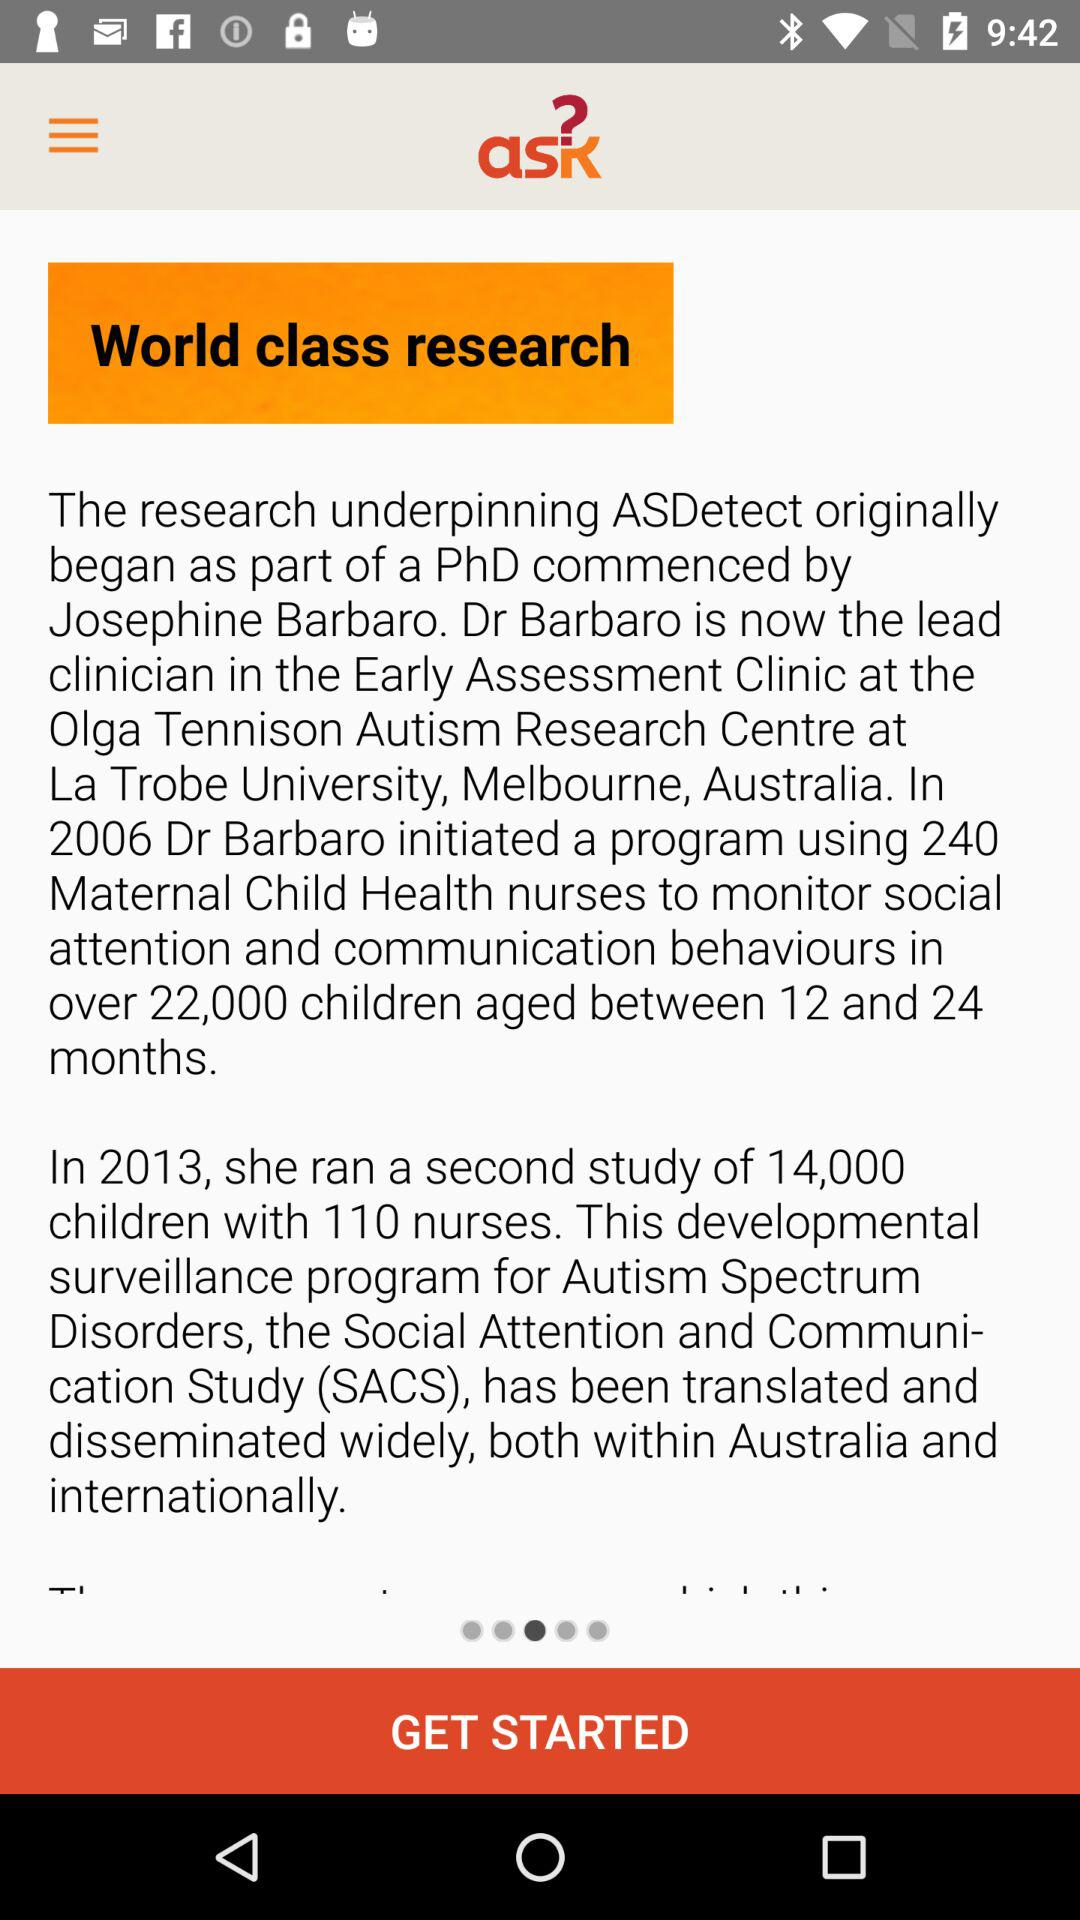How many years apart were the two studies that Dr Barbaro conducted?
Answer the question using a single word or phrase. 7 